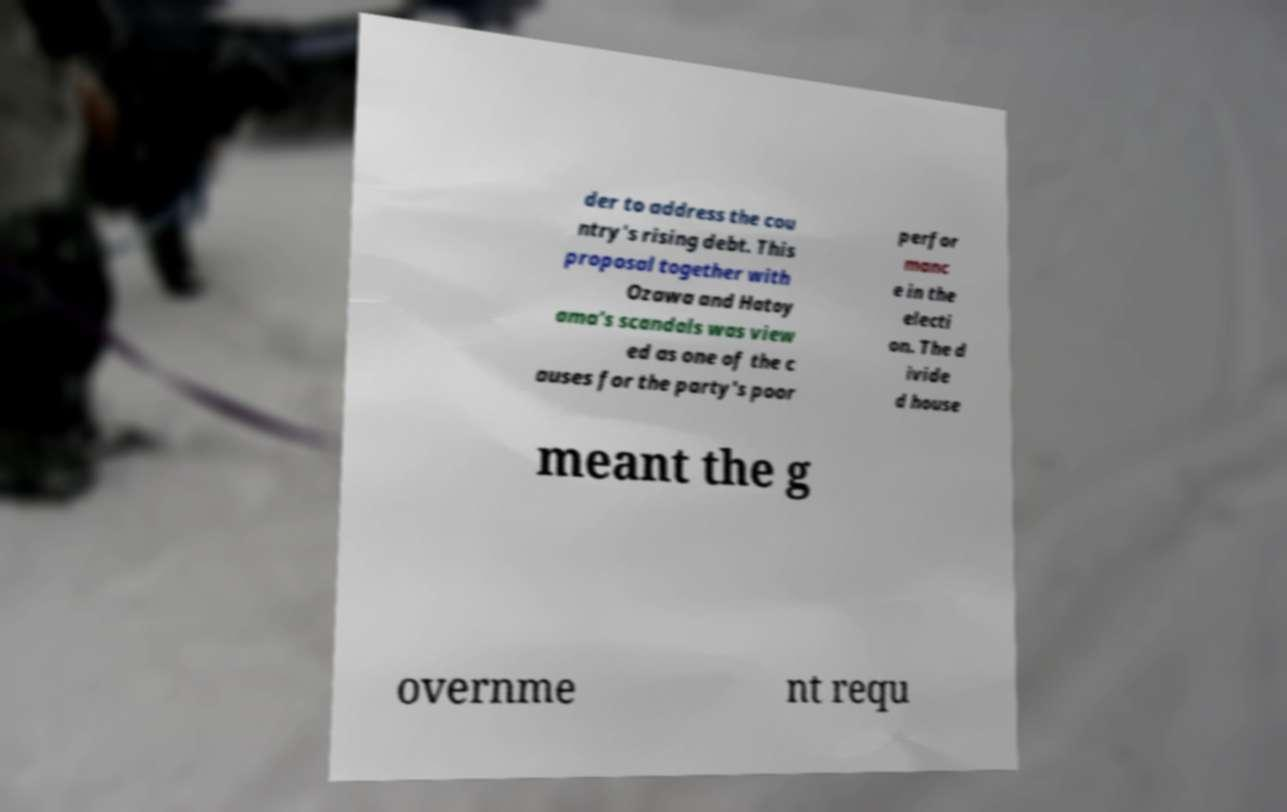Could you extract and type out the text from this image? der to address the cou ntry's rising debt. This proposal together with Ozawa and Hatoy ama's scandals was view ed as one of the c auses for the party's poor perfor manc e in the electi on. The d ivide d house meant the g overnme nt requ 